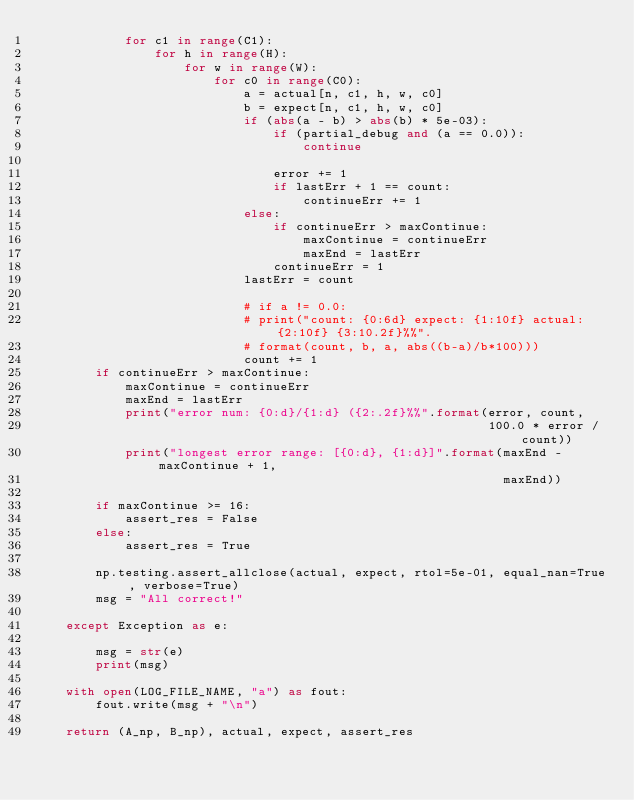Convert code to text. <code><loc_0><loc_0><loc_500><loc_500><_Python_>            for c1 in range(C1):
                for h in range(H):
                    for w in range(W):
                        for c0 in range(C0):
                            a = actual[n, c1, h, w, c0]
                            b = expect[n, c1, h, w, c0]
                            if (abs(a - b) > abs(b) * 5e-03):
                                if (partial_debug and (a == 0.0)):
                                    continue

                                error += 1
                                if lastErr + 1 == count:
                                    continueErr += 1
                            else:
                                if continueErr > maxContinue:
                                    maxContinue = continueErr
                                    maxEnd = lastErr
                                continueErr = 1
                            lastErr = count

                            # if a != 0.0:
                            # print("count: {0:6d} expect: {1:10f} actual: {2:10f} {3:10.2f}%%".
                            # format(count, b, a, abs((b-a)/b*100)))
                            count += 1
        if continueErr > maxContinue:
            maxContinue = continueErr
            maxEnd = lastErr
            print("error num: {0:d}/{1:d} ({2:.2f}%%".format(error, count,
                                                             100.0 * error / count))
            print("longest error range: [{0:d}, {1:d}]".format(maxEnd - maxContinue + 1,
                                                               maxEnd))

        if maxContinue >= 16:
            assert_res = False
        else:
            assert_res = True

        np.testing.assert_allclose(actual, expect, rtol=5e-01, equal_nan=True, verbose=True)
        msg = "All correct!"

    except Exception as e:

        msg = str(e)
        print(msg)

    with open(LOG_FILE_NAME, "a") as fout:
        fout.write(msg + "\n")

    return (A_np, B_np), actual, expect, assert_res
</code> 